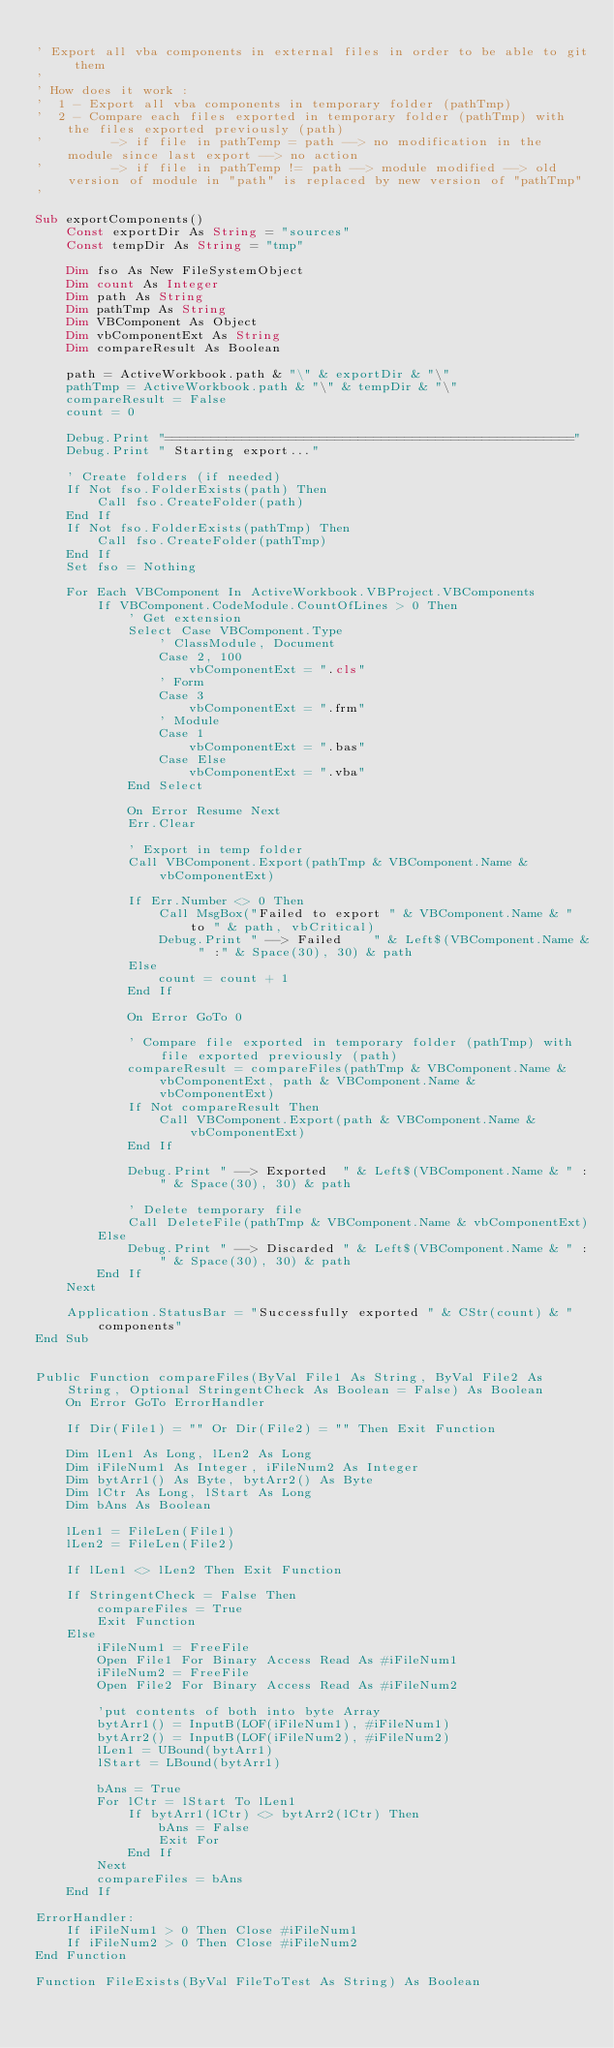Convert code to text. <code><loc_0><loc_0><loc_500><loc_500><_VisualBasic_>
' Export all vba components in external files in order to be able to git them
'
' How does it work :
'  1 - Export all vba components in temporary folder (pathTmp)
'  2 - Compare each files exported in temporary folder (pathTmp) with the files exported previously (path)
'         -> if file in pathTemp = path --> no modification in the module since last export --> no action
'         -> if file in pathTemp != path --> module modified --> old version of module in "path" is replaced by new version of "pathTmp"
'

Sub exportComponents()
    Const exportDir As String = "sources"
    Const tempDir As String = "tmp"
    
    Dim fso As New FileSystemObject
    Dim count As Integer
    Dim path As String
    Dim pathTmp As String
    Dim VBComponent As Object
    Dim vbComponentExt As String
    Dim compareResult As Boolean
    
    path = ActiveWorkbook.path & "\" & exportDir & "\"
    pathTmp = ActiveWorkbook.path & "\" & tempDir & "\"
    compareResult = False
    count = 0
    
    Debug.Print "====================================================="
    Debug.Print " Starting export..."

    ' Create folders (if needed)
    If Not fso.FolderExists(path) Then
        Call fso.CreateFolder(path)
    End If
    If Not fso.FolderExists(pathTmp) Then
        Call fso.CreateFolder(pathTmp)
    End If
    Set fso = Nothing
    
    For Each VBComponent In ActiveWorkbook.VBProject.VBComponents
        If VBComponent.CodeModule.CountOfLines > 0 Then
            ' Get extension
            Select Case VBComponent.Type
                ' ClassModule, Document
                Case 2, 100
                    vbComponentExt = ".cls"
                ' Form
                Case 3
                    vbComponentExt = ".frm"
                ' Module
                Case 1
                    vbComponentExt = ".bas"
                Case Else
                    vbComponentExt = ".vba"
            End Select
            
            On Error Resume Next
            Err.Clear
            
            ' Export in temp folder
            Call VBComponent.Export(pathTmp & VBComponent.Name & vbComponentExt)
            
            If Err.Number <> 0 Then
                Call MsgBox("Failed to export " & VBComponent.Name & " to " & path, vbCritical)
                Debug.Print " --> Failed    " & Left$(VBComponent.Name & " :" & Space(30), 30) & path
            Else
                count = count + 1
            End If
            
            On Error GoTo 0
            
            ' Compare file exported in temporary folder (pathTmp) with file exported previously (path)
            compareResult = compareFiles(pathTmp & VBComponent.Name & vbComponentExt, path & VBComponent.Name & vbComponentExt)
            If Not compareResult Then
                Call VBComponent.Export(path & VBComponent.Name & vbComponentExt)
            End If
            
            Debug.Print " --> Exported  " & Left$(VBComponent.Name & " :" & Space(30), 30) & path
            
            ' Delete temporary file
            Call DeleteFile(pathTmp & VBComponent.Name & vbComponentExt)
        Else
            Debug.Print " --> Discarded " & Left$(VBComponent.Name & " :" & Space(30), 30) & path
        End If
    Next
    
    Application.StatusBar = "Successfully exported " & CStr(count) & " components"
End Sub


Public Function compareFiles(ByVal File1 As String, ByVal File2 As String, Optional StringentCheck As Boolean = False) As Boolean
    On Error GoTo ErrorHandler

    If Dir(File1) = "" Or Dir(File2) = "" Then Exit Function

    Dim lLen1 As Long, lLen2 As Long
    Dim iFileNum1 As Integer, iFileNum2 As Integer
    Dim bytArr1() As Byte, bytArr2() As Byte
    Dim lCtr As Long, lStart As Long
    Dim bAns As Boolean

    lLen1 = FileLen(File1)
    lLen2 = FileLen(File2)

    If lLen1 <> lLen2 Then Exit Function

    If StringentCheck = False Then
        compareFiles = True
        Exit Function
    Else
        iFileNum1 = FreeFile
        Open File1 For Binary Access Read As #iFileNum1
        iFileNum2 = FreeFile
        Open File2 For Binary Access Read As #iFileNum2
    
        'put contents of both into byte Array
        bytArr1() = InputB(LOF(iFileNum1), #iFileNum1)
        bytArr2() = InputB(LOF(iFileNum2), #iFileNum2)
        lLen1 = UBound(bytArr1)
        lStart = LBound(bytArr1)
        
        bAns = True
        For lCtr = lStart To lLen1
            If bytArr1(lCtr) <> bytArr2(lCtr) Then
                bAns = False
                Exit For
            End If
        Next
        compareFiles = bAns
    End If
 
ErrorHandler:
    If iFileNum1 > 0 Then Close #iFileNum1
    If iFileNum2 > 0 Then Close #iFileNum2
End Function

Function FileExists(ByVal FileToTest As String) As Boolean</code> 